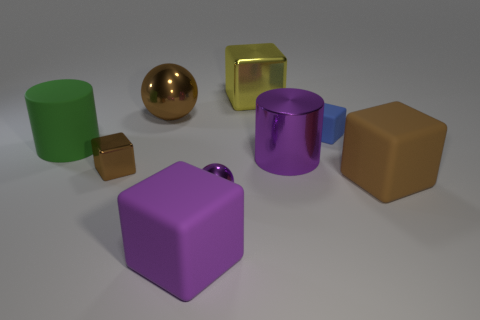Are there more green matte cylinders than red things?
Offer a terse response. Yes. Are there any other things of the same color as the large rubber cylinder?
Your response must be concise. No. The purple cylinder that is the same material as the yellow cube is what size?
Your answer should be very brief. Large. What is the large ball made of?
Ensure brevity in your answer.  Metal. How many red shiny spheres have the same size as the yellow thing?
Make the answer very short. 0. The tiny metallic object that is the same color as the big metal sphere is what shape?
Your answer should be very brief. Cube. Are there any large blue matte objects of the same shape as the big green thing?
Keep it short and to the point. No. What is the color of the metallic ball that is the same size as the blue matte block?
Make the answer very short. Purple. What color is the big cube that is behind the big green matte cylinder that is in front of the big brown sphere?
Offer a terse response. Yellow. Does the metallic cube to the right of the tiny brown thing have the same color as the small rubber thing?
Offer a very short reply. No. 